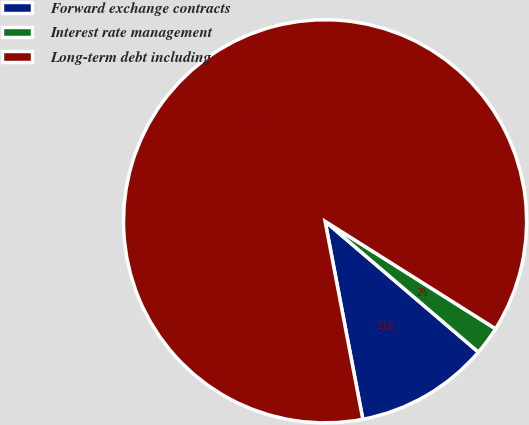Convert chart. <chart><loc_0><loc_0><loc_500><loc_500><pie_chart><fcel>Forward exchange contracts<fcel>Interest rate management<fcel>Long-term debt including<nl><fcel>10.76%<fcel>2.29%<fcel>86.95%<nl></chart> 